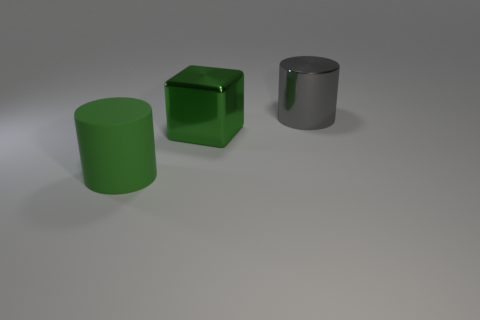Add 2 large green balls. How many objects exist? 5 Subtract all cylinders. How many objects are left? 1 Add 1 matte objects. How many matte objects are left? 2 Add 1 yellow balls. How many yellow balls exist? 1 Subtract 0 red spheres. How many objects are left? 3 Subtract all big green cubes. Subtract all large blue metallic things. How many objects are left? 2 